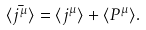<formula> <loc_0><loc_0><loc_500><loc_500>\langle \bar { j ^ { \mu } } \rangle = \langle j ^ { \mu } \rangle + \langle P ^ { \mu } \rangle .</formula> 